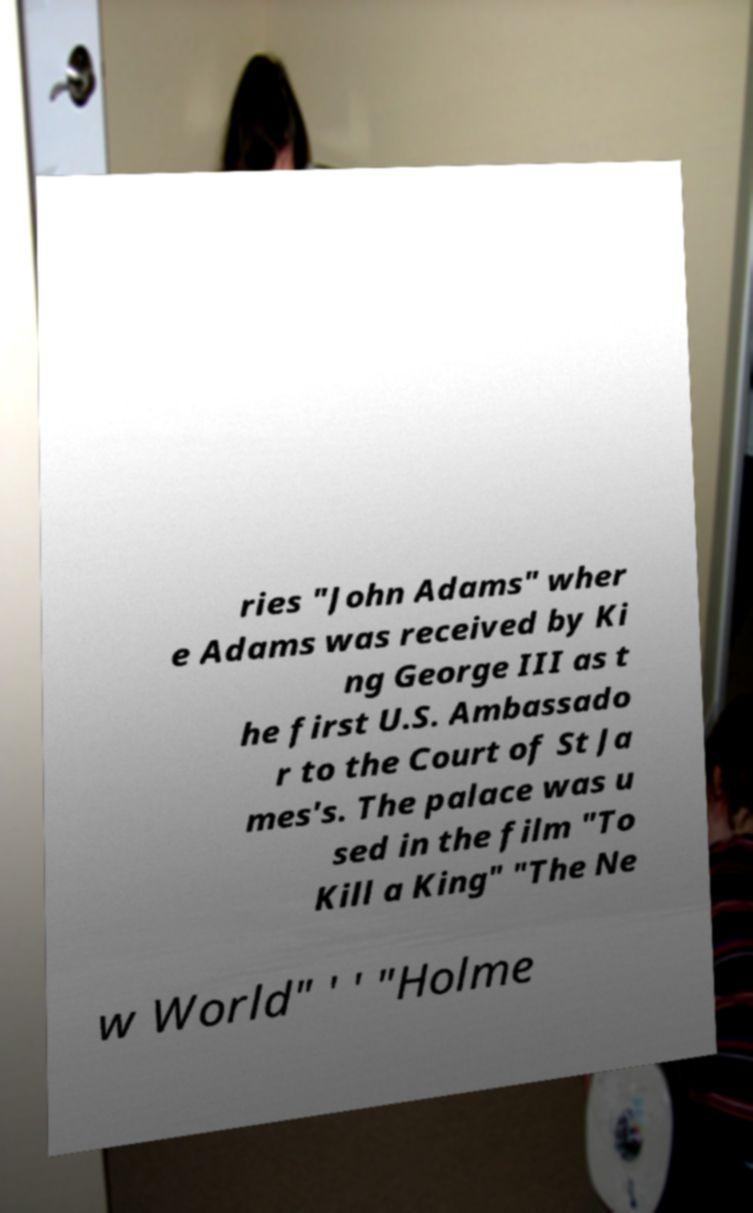Please read and relay the text visible in this image. What does it say? ries "John Adams" wher e Adams was received by Ki ng George III as t he first U.S. Ambassado r to the Court of St Ja mes's. The palace was u sed in the film "To Kill a King" "The Ne w World" ' ' "Holme 